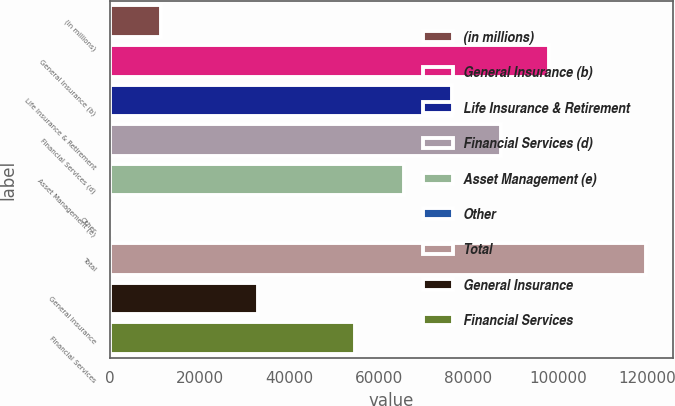<chart> <loc_0><loc_0><loc_500><loc_500><bar_chart><fcel>(in millions)<fcel>General Insurance (b)<fcel>Life Insurance & Retirement<fcel>Financial Services (d)<fcel>Asset Management (e)<fcel>Other<fcel>Total<fcel>General Insurance<fcel>Financial Services<nl><fcel>11399<fcel>98071<fcel>76403<fcel>87237<fcel>65569<fcel>565<fcel>119739<fcel>33067<fcel>54735<nl></chart> 